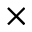<formula> <loc_0><loc_0><loc_500><loc_500>\times</formula> 